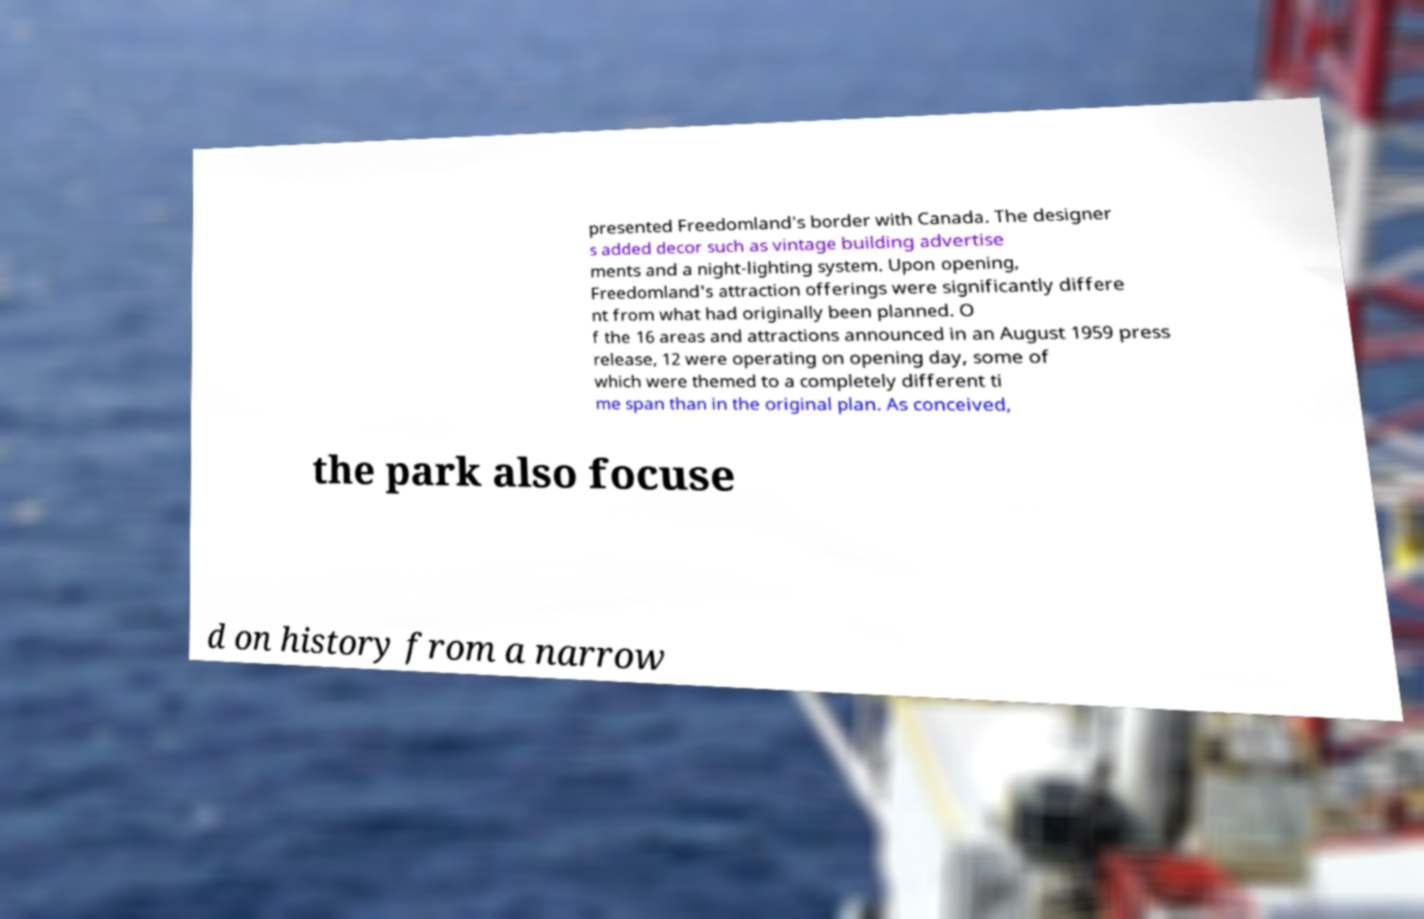Could you assist in decoding the text presented in this image and type it out clearly? presented Freedomland's border with Canada. The designer s added decor such as vintage building advertise ments and a night-lighting system. Upon opening, Freedomland's attraction offerings were significantly differe nt from what had originally been planned. O f the 16 areas and attractions announced in an August 1959 press release, 12 were operating on opening day, some of which were themed to a completely different ti me span than in the original plan. As conceived, the park also focuse d on history from a narrow 